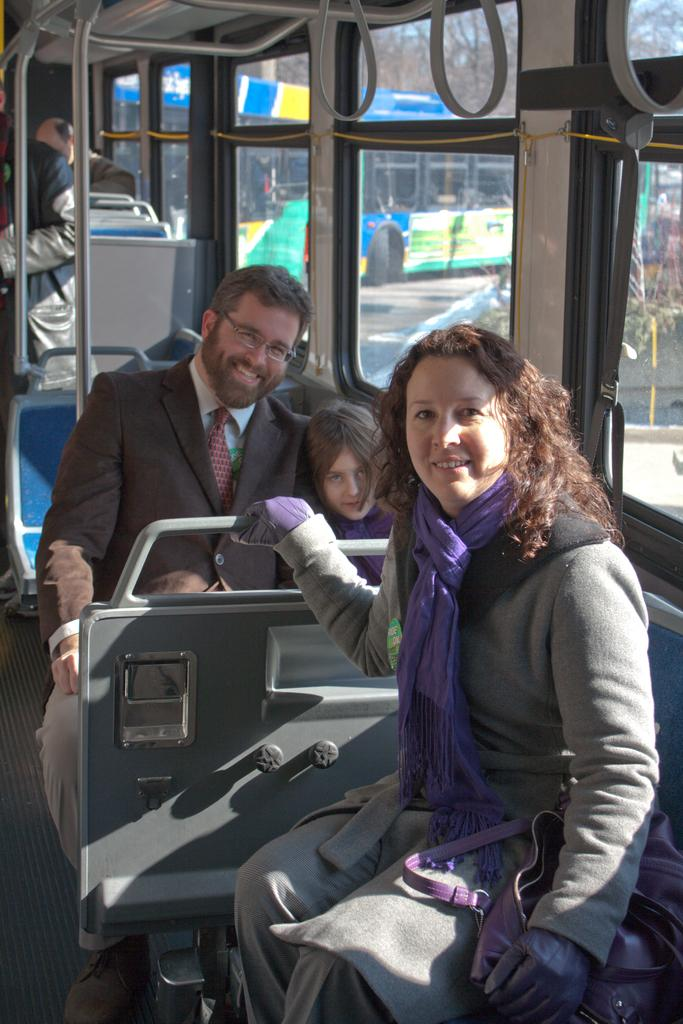How many people are visible in the image? There are three people visible in the image: a woman, a man, and a kid. What are the woman, man, and kid doing in the image? They are sitting in seats. Are there any other people present in the image? Yes, there are other persons sitting in the backdrop. What can be seen through the window in the image? Trees and plants are visible from a window in the image. What type of underwear is the woman wearing in the image? There is no information about the woman's underwear in the image, and therefore it cannot be determined. 